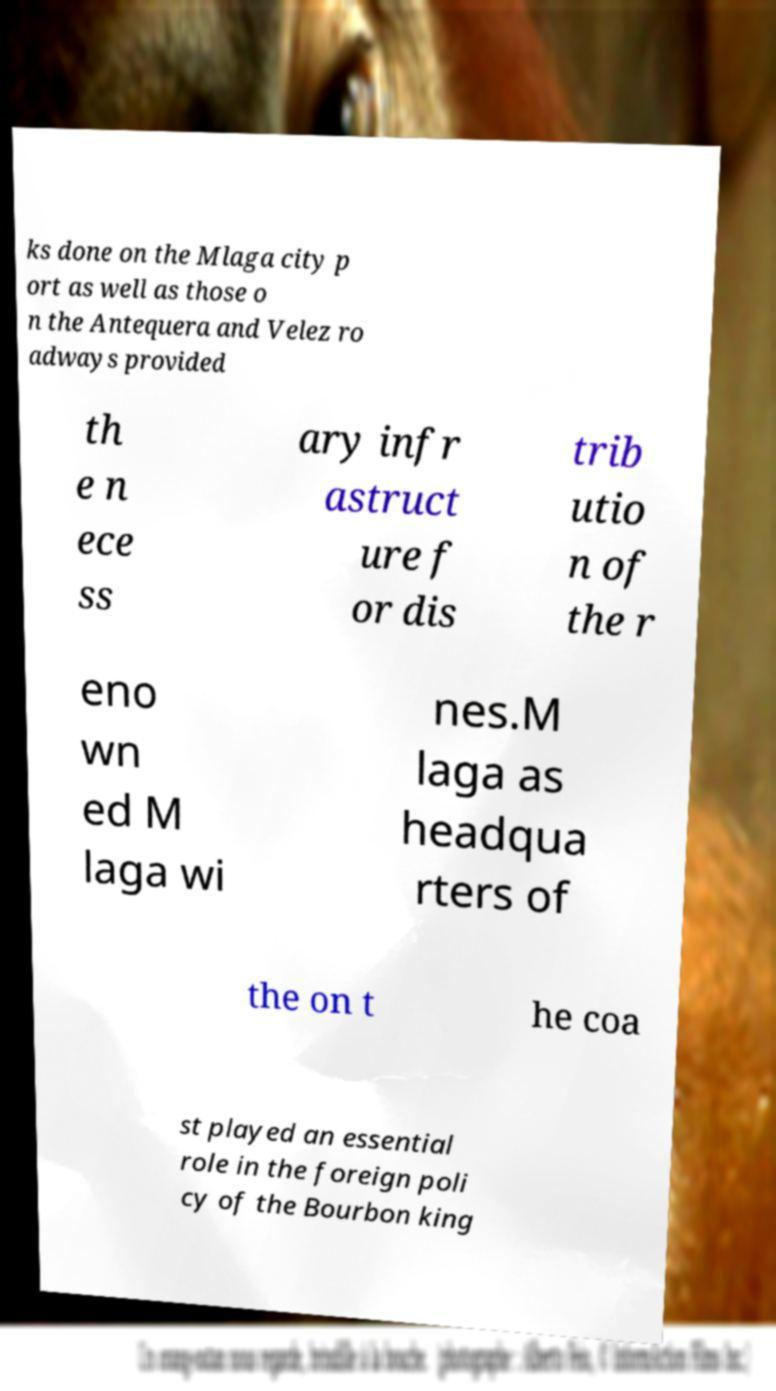For documentation purposes, I need the text within this image transcribed. Could you provide that? ks done on the Mlaga city p ort as well as those o n the Antequera and Velez ro adways provided th e n ece ss ary infr astruct ure f or dis trib utio n of the r eno wn ed M laga wi nes.M laga as headqua rters of the on t he coa st played an essential role in the foreign poli cy of the Bourbon king 